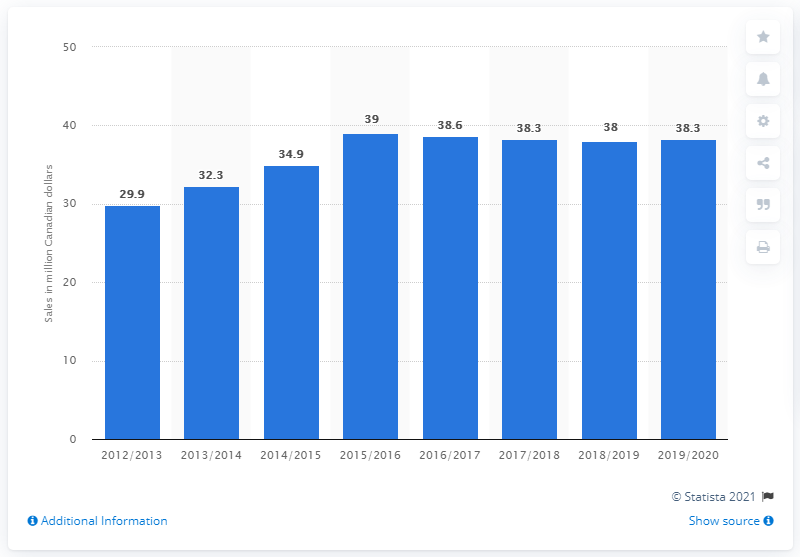List a handful of essential elements in this visual. The retail sales of beer in Newfoundland and Labrador in 2019/20 were approximately 38.3 million dollars. 